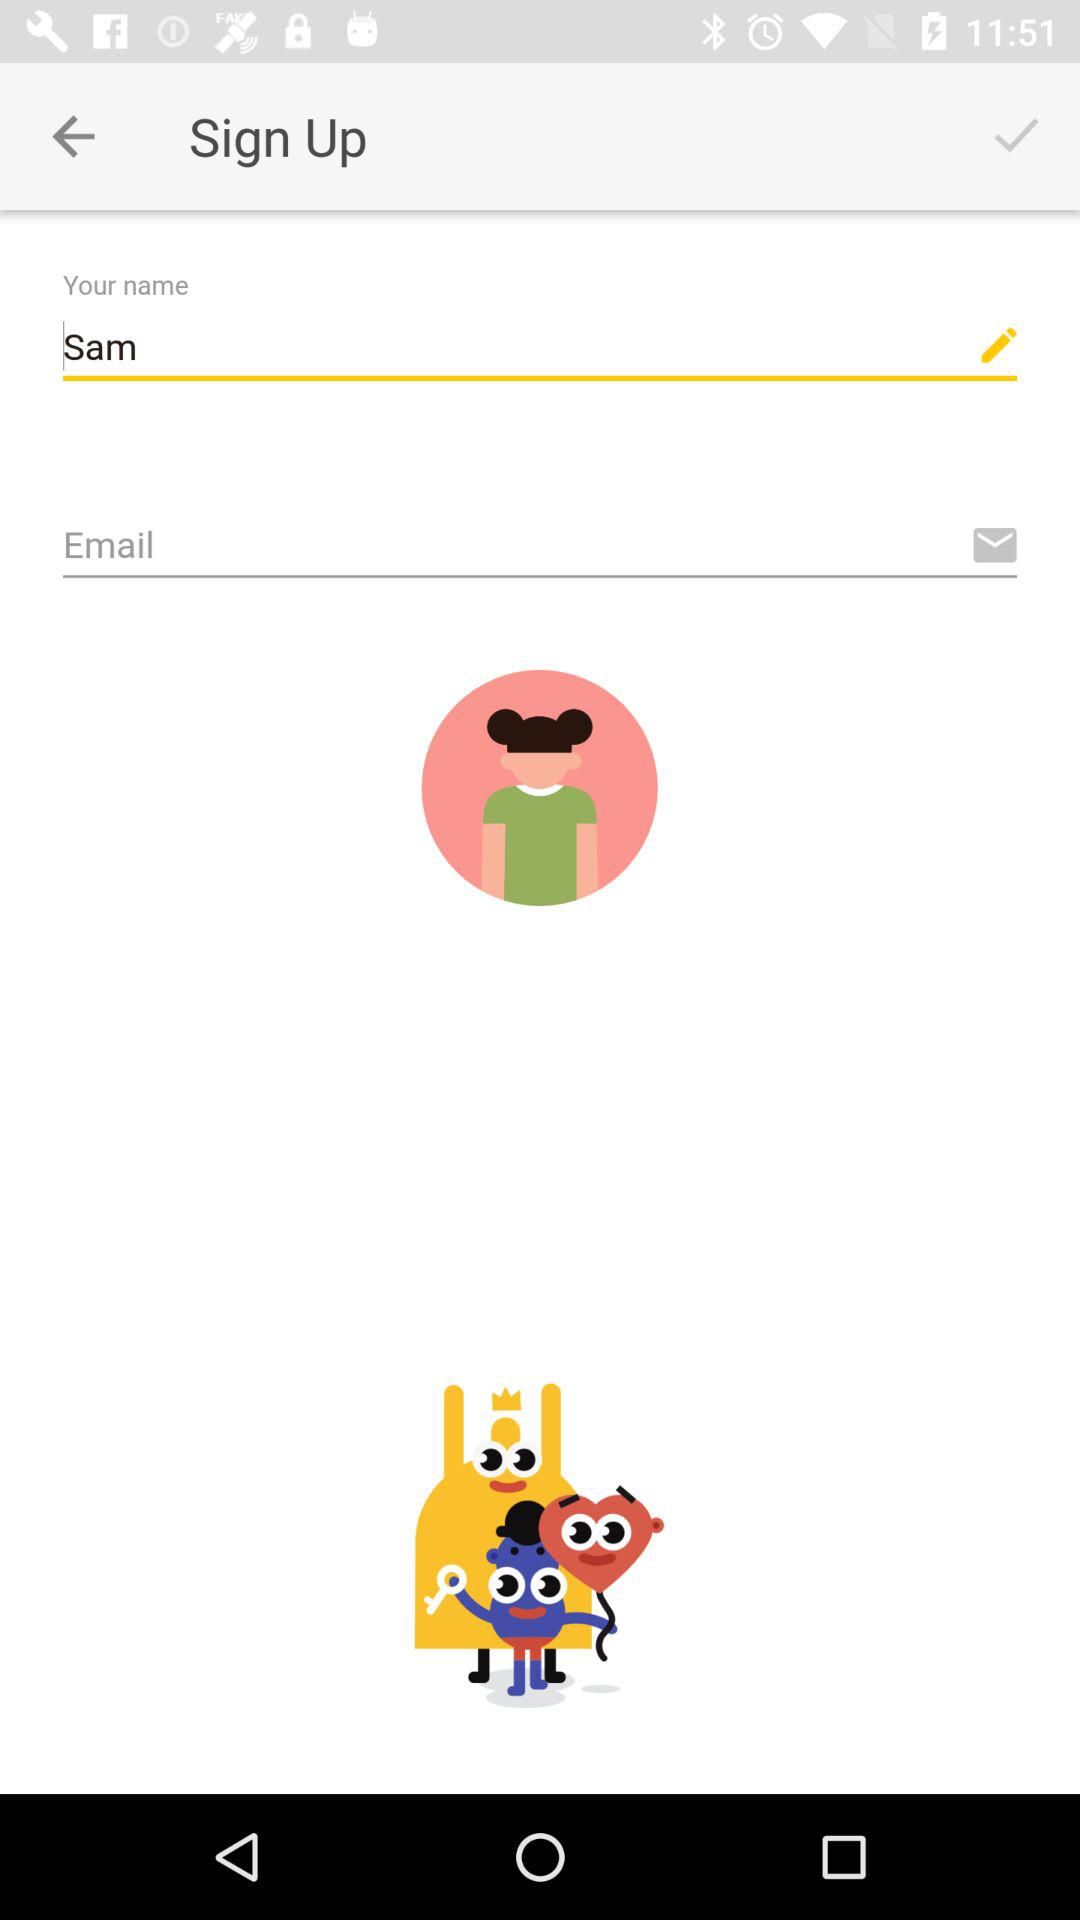What is the user name? The user name is Sam. 